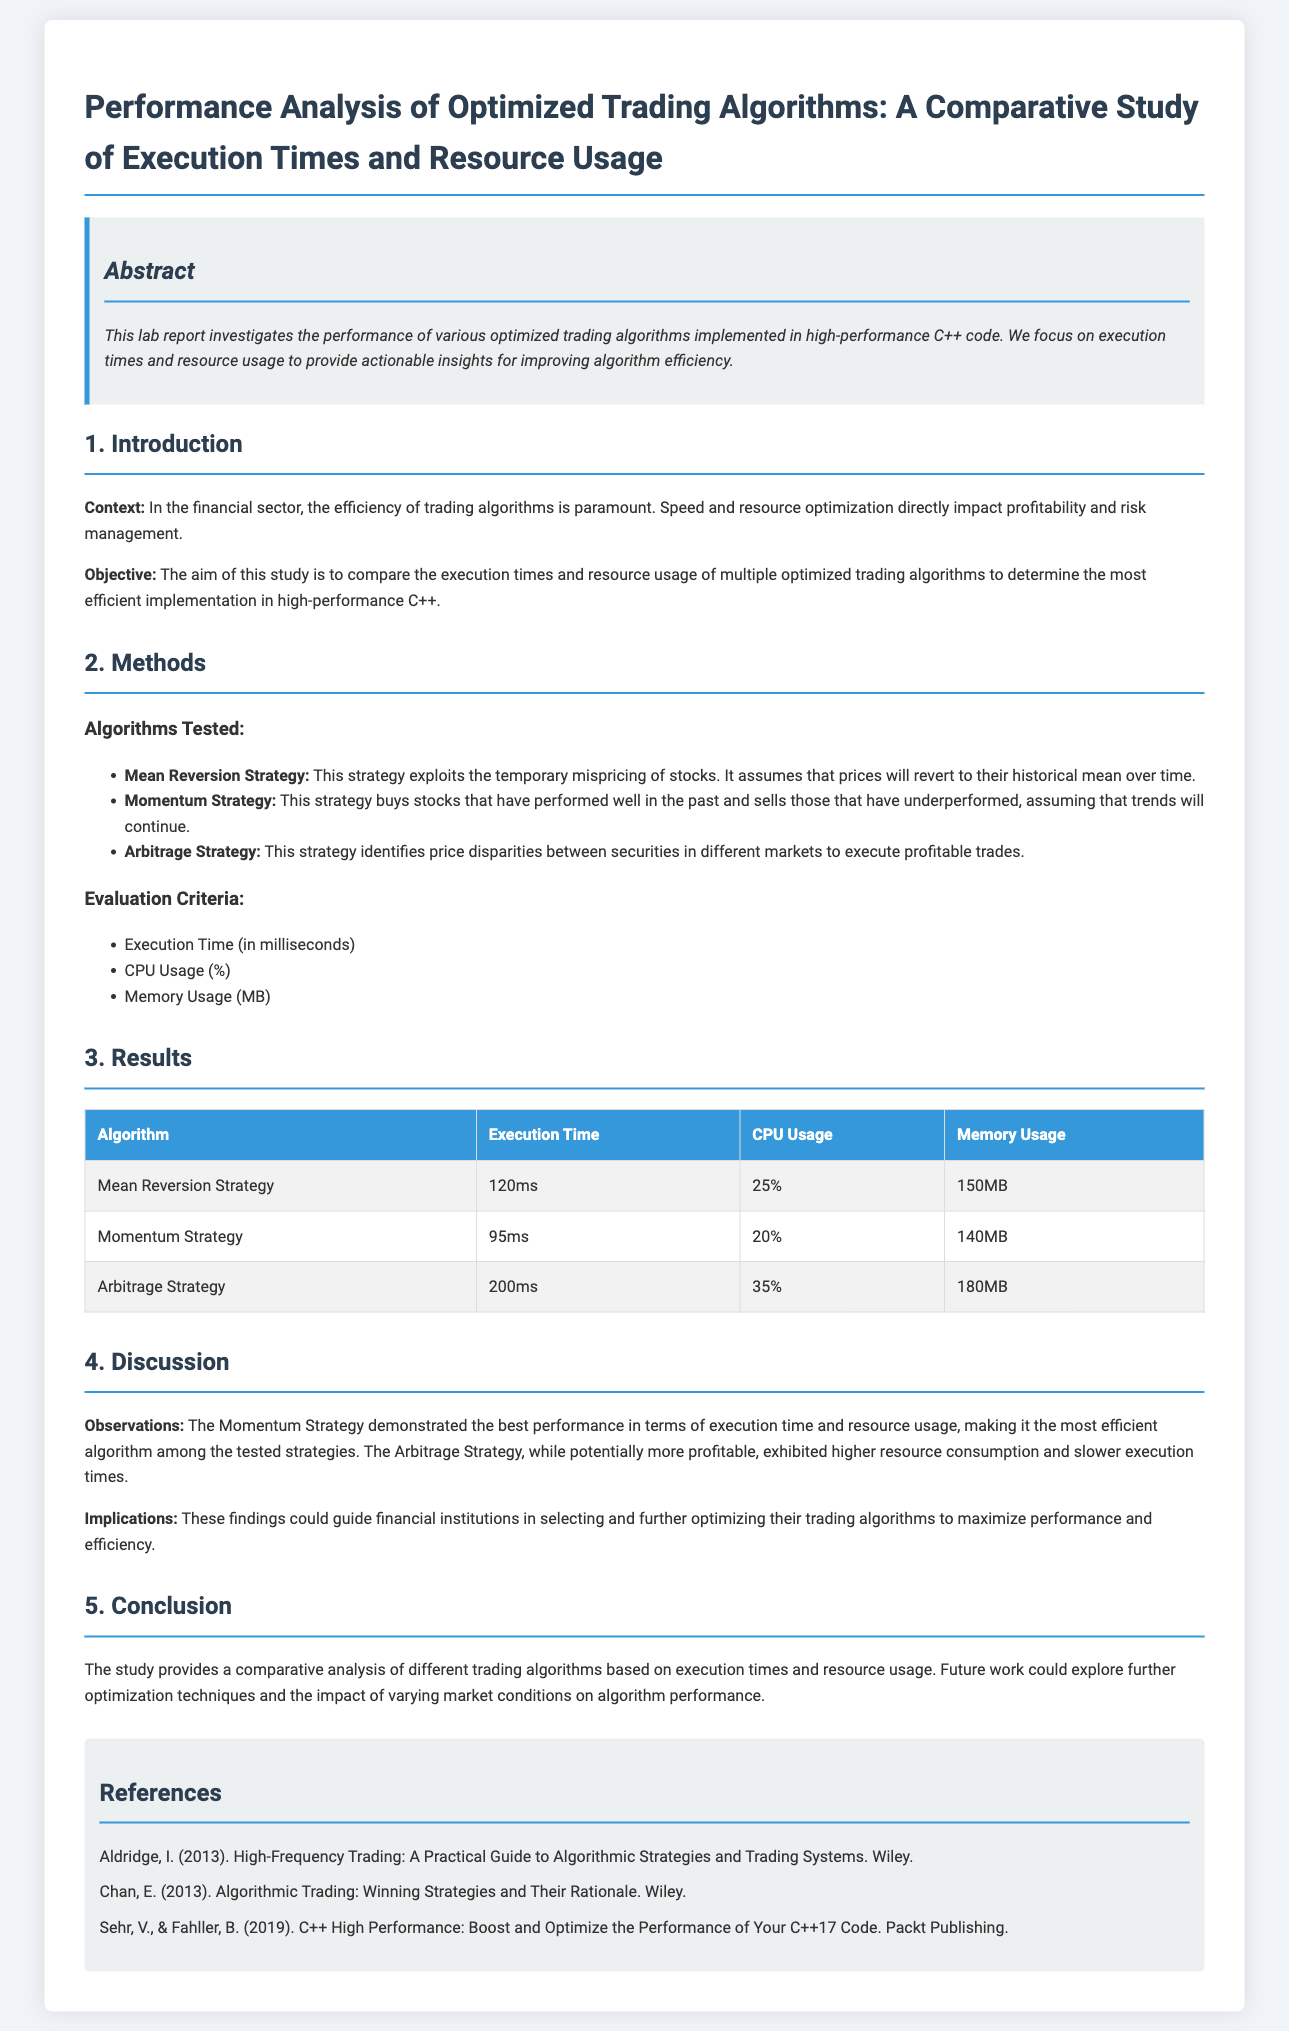What is the title of the lab report? The title is stated at the top of the document, summarizing the study on trading algorithms.
Answer: Performance Analysis of Optimized Trading Algorithms: A Comparative Study of Execution Times and Resource Usage What is the execution time of the Momentum Strategy? The execution time for each algorithm is presented in a table in the Results section.
Answer: 95ms Which strategy has the highest CPU usage? The CPU usage for each strategy is listed in the Results table; examining these reveals the strategy with the highest percentage.
Answer: Arbitrage Strategy What is the objective of the study? The objective is summarized in the Introduction section, outlining the aim of comparing algorithms' efficiency.
Answer: Compare execution times and resource usage What is the memory usage of the Mean Reversion Strategy? The memory usage for each algorithm is displayed in the Results section's table.
Answer: 150MB Which strategy was determined to be the most efficient? The Discussion section analyzes the performance and identifies the most efficient algorithm based on the results.
Answer: Momentum Strategy What year was the book by Aldridge published? The publication date for referenced literature is mentioned in the References section.
Answer: 2013 What are the three evaluation criteria used in the study? The evaluation criteria are listed clearly in the Methods section under Evaluation Criteria.
Answer: Execution Time, CPU Usage, Memory Usage 